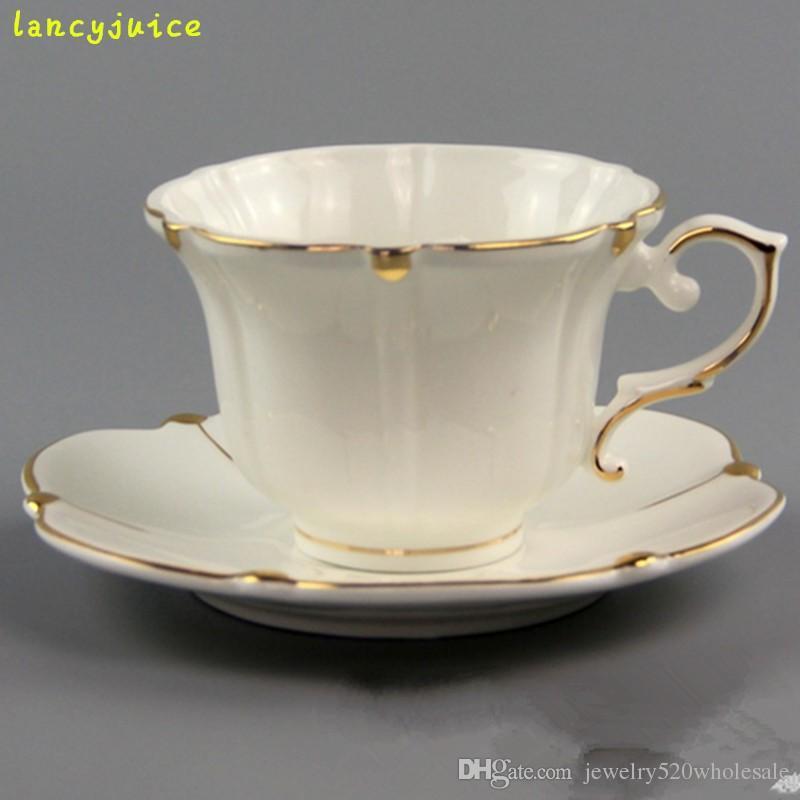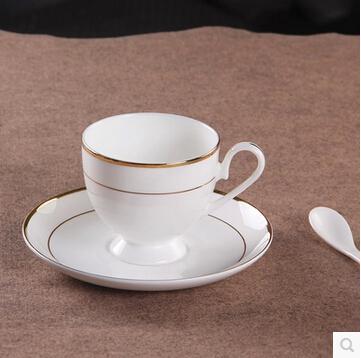The first image is the image on the left, the second image is the image on the right. Considering the images on both sides, is "An image contains exactly four cups on saucers." valid? Answer yes or no. No. The first image is the image on the left, the second image is the image on the right. Considering the images on both sides, is "There are two teacup and saucer sets" valid? Answer yes or no. Yes. 